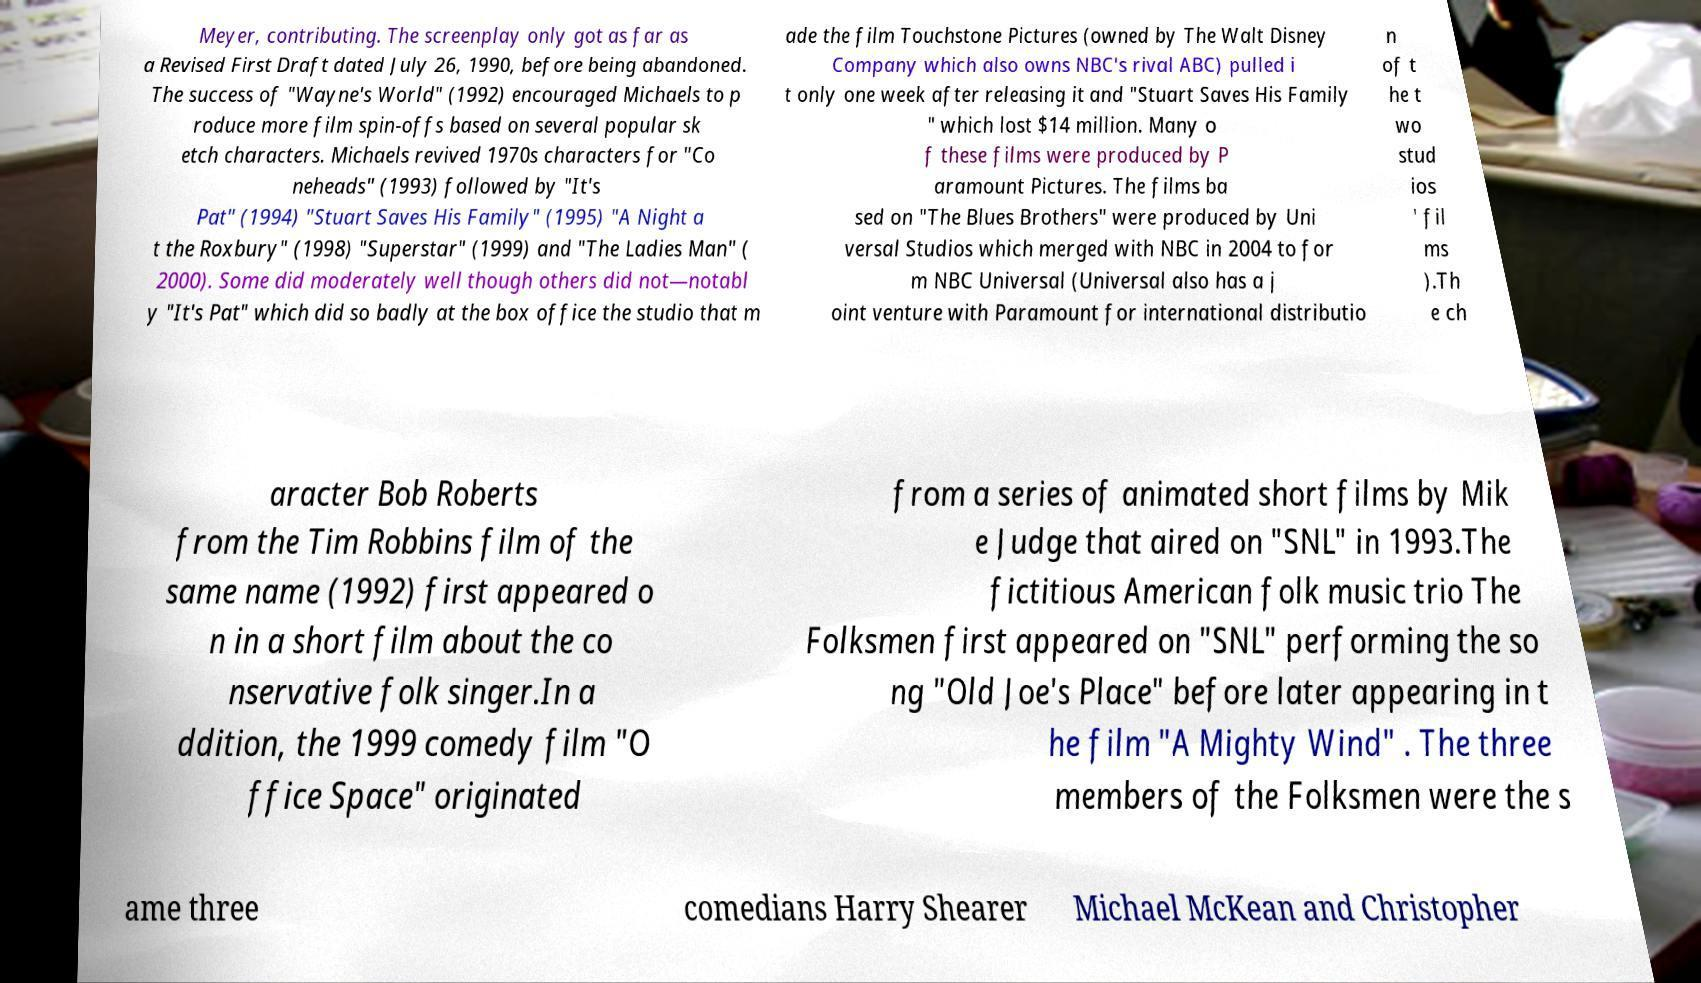There's text embedded in this image that I need extracted. Can you transcribe it verbatim? Meyer, contributing. The screenplay only got as far as a Revised First Draft dated July 26, 1990, before being abandoned. The success of "Wayne's World" (1992) encouraged Michaels to p roduce more film spin-offs based on several popular sk etch characters. Michaels revived 1970s characters for "Co neheads" (1993) followed by "It's Pat" (1994) "Stuart Saves His Family" (1995) "A Night a t the Roxbury" (1998) "Superstar" (1999) and "The Ladies Man" ( 2000). Some did moderately well though others did not—notabl y "It's Pat" which did so badly at the box office the studio that m ade the film Touchstone Pictures (owned by The Walt Disney Company which also owns NBC's rival ABC) pulled i t only one week after releasing it and "Stuart Saves His Family " which lost $14 million. Many o f these films were produced by P aramount Pictures. The films ba sed on "The Blues Brothers" were produced by Uni versal Studios which merged with NBC in 2004 to for m NBC Universal (Universal also has a j oint venture with Paramount for international distributio n of t he t wo stud ios ' fil ms ).Th e ch aracter Bob Roberts from the Tim Robbins film of the same name (1992) first appeared o n in a short film about the co nservative folk singer.In a ddition, the 1999 comedy film "O ffice Space" originated from a series of animated short films by Mik e Judge that aired on "SNL" in 1993.The fictitious American folk music trio The Folksmen first appeared on "SNL" performing the so ng "Old Joe's Place" before later appearing in t he film "A Mighty Wind" . The three members of the Folksmen were the s ame three comedians Harry Shearer Michael McKean and Christopher 